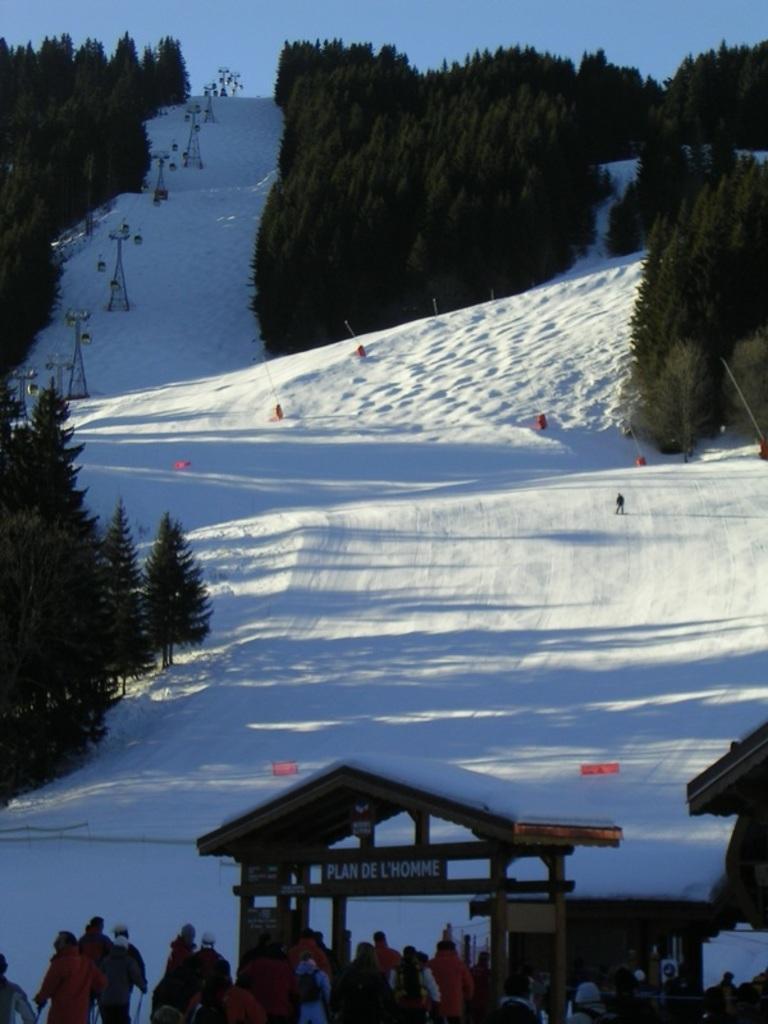Could you give a brief overview of what you see in this image? In this image we can see mountain full of snow, trees and towers. Bottom of the image one entry gate is there and people are entering into it. 